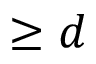<formula> <loc_0><loc_0><loc_500><loc_500>\geq d</formula> 